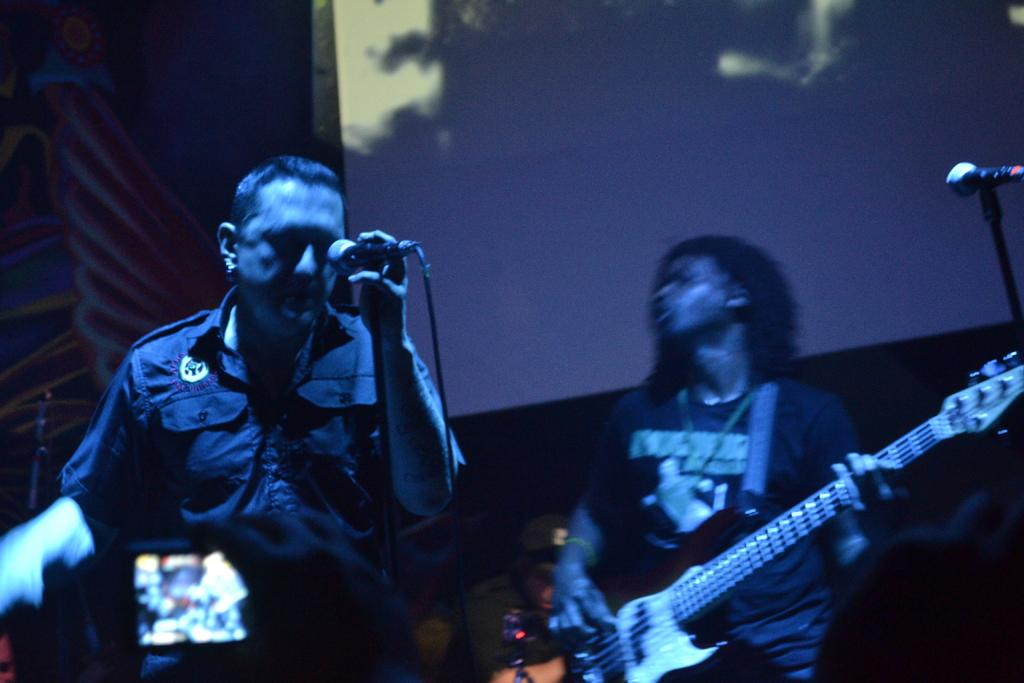How many people are visible in the image? There are people standing in the image. What are the people holding in the image? One person is holding a microphone, and another person is holding a guitar. What can be seen in the background of the image? There is a screen in the image. How is the microphone being supported? The microphone is attached to a mic holder. How many clams are visible on the guitar in the image? There are no clams visible on the guitar in the image. What type of mice can be seen interacting with the microphone in the image? There are no mice present in the image; the people are the only subjects visible. 